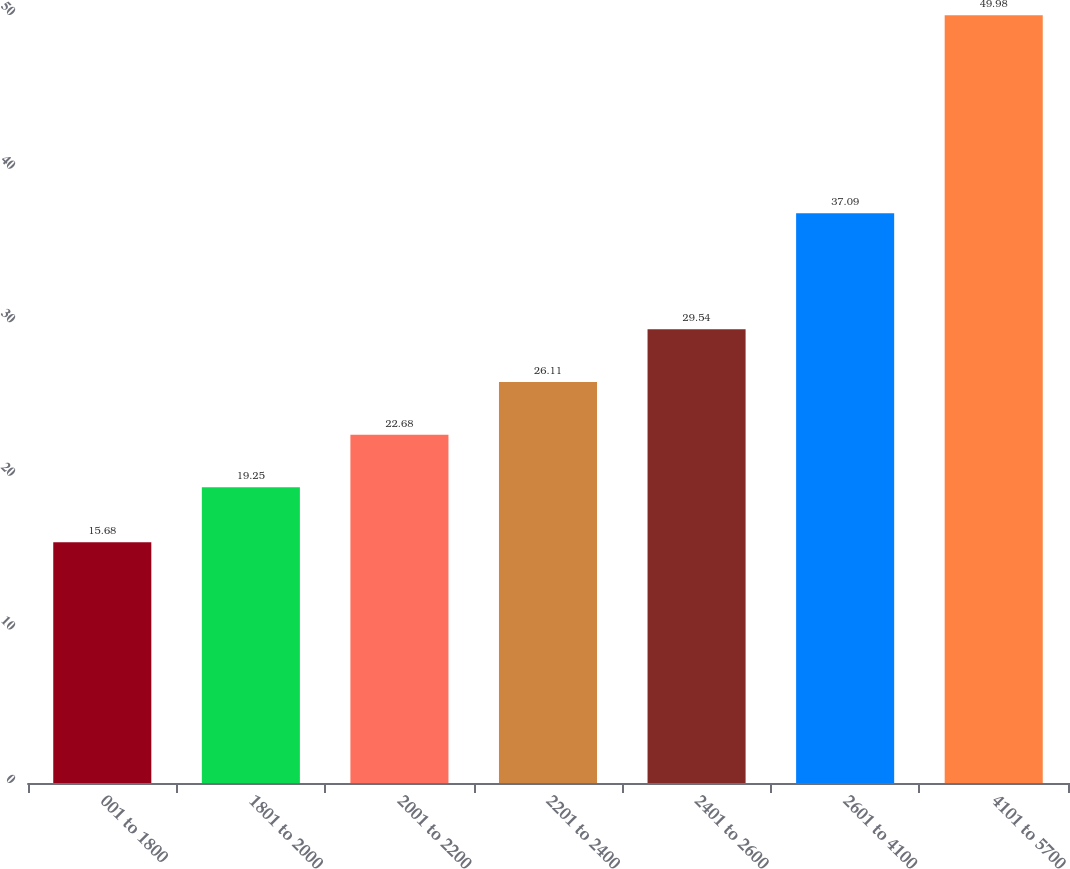Convert chart to OTSL. <chart><loc_0><loc_0><loc_500><loc_500><bar_chart><fcel>001 to 1800<fcel>1801 to 2000<fcel>2001 to 2200<fcel>2201 to 2400<fcel>2401 to 2600<fcel>2601 to 4100<fcel>4101 to 5700<nl><fcel>15.68<fcel>19.25<fcel>22.68<fcel>26.11<fcel>29.54<fcel>37.09<fcel>49.98<nl></chart> 